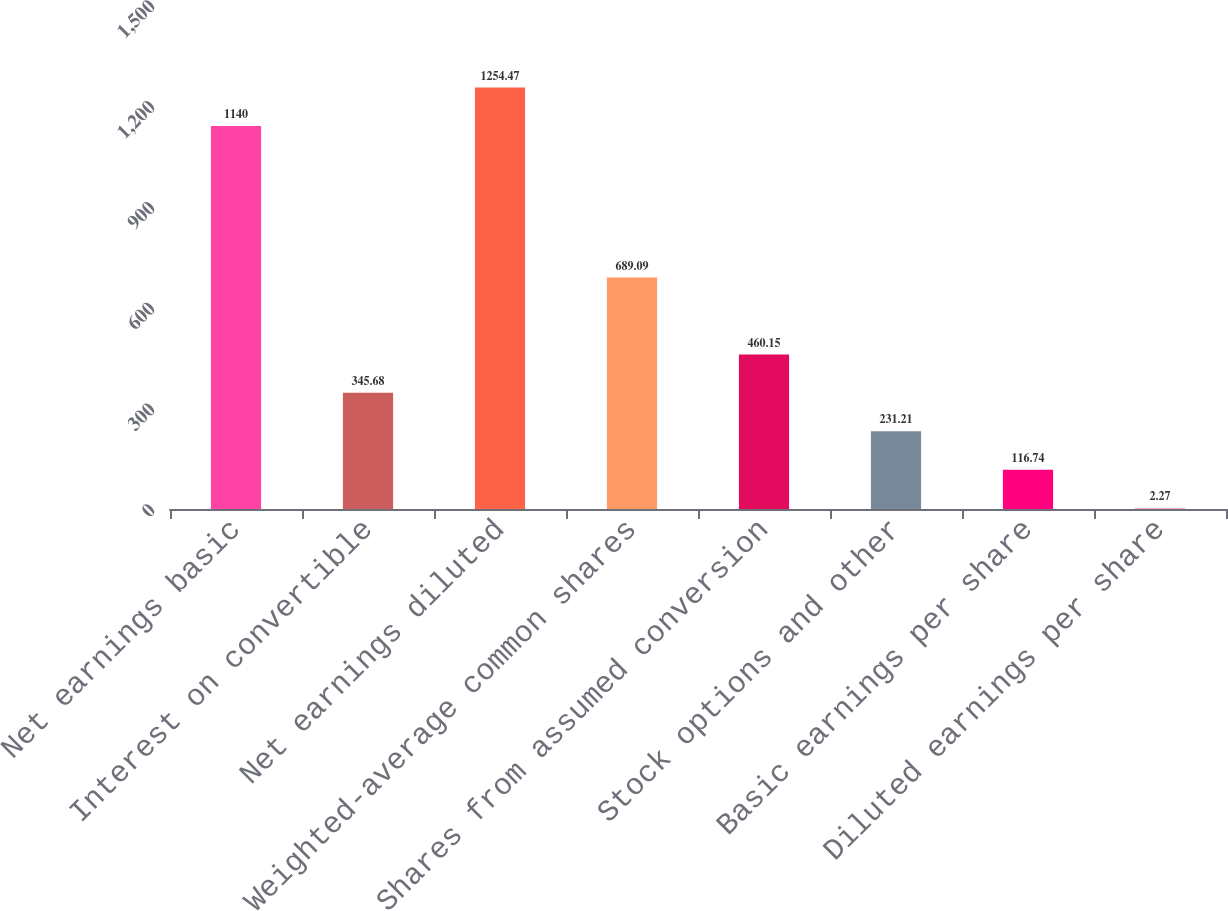<chart> <loc_0><loc_0><loc_500><loc_500><bar_chart><fcel>Net earnings basic<fcel>Interest on convertible<fcel>Net earnings diluted<fcel>Weighted-average common shares<fcel>Shares from assumed conversion<fcel>Stock options and other<fcel>Basic earnings per share<fcel>Diluted earnings per share<nl><fcel>1140<fcel>345.68<fcel>1254.47<fcel>689.09<fcel>460.15<fcel>231.21<fcel>116.74<fcel>2.27<nl></chart> 